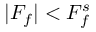Convert formula to latex. <formula><loc_0><loc_0><loc_500><loc_500>| F _ { f } | < F _ { f } ^ { s }</formula> 